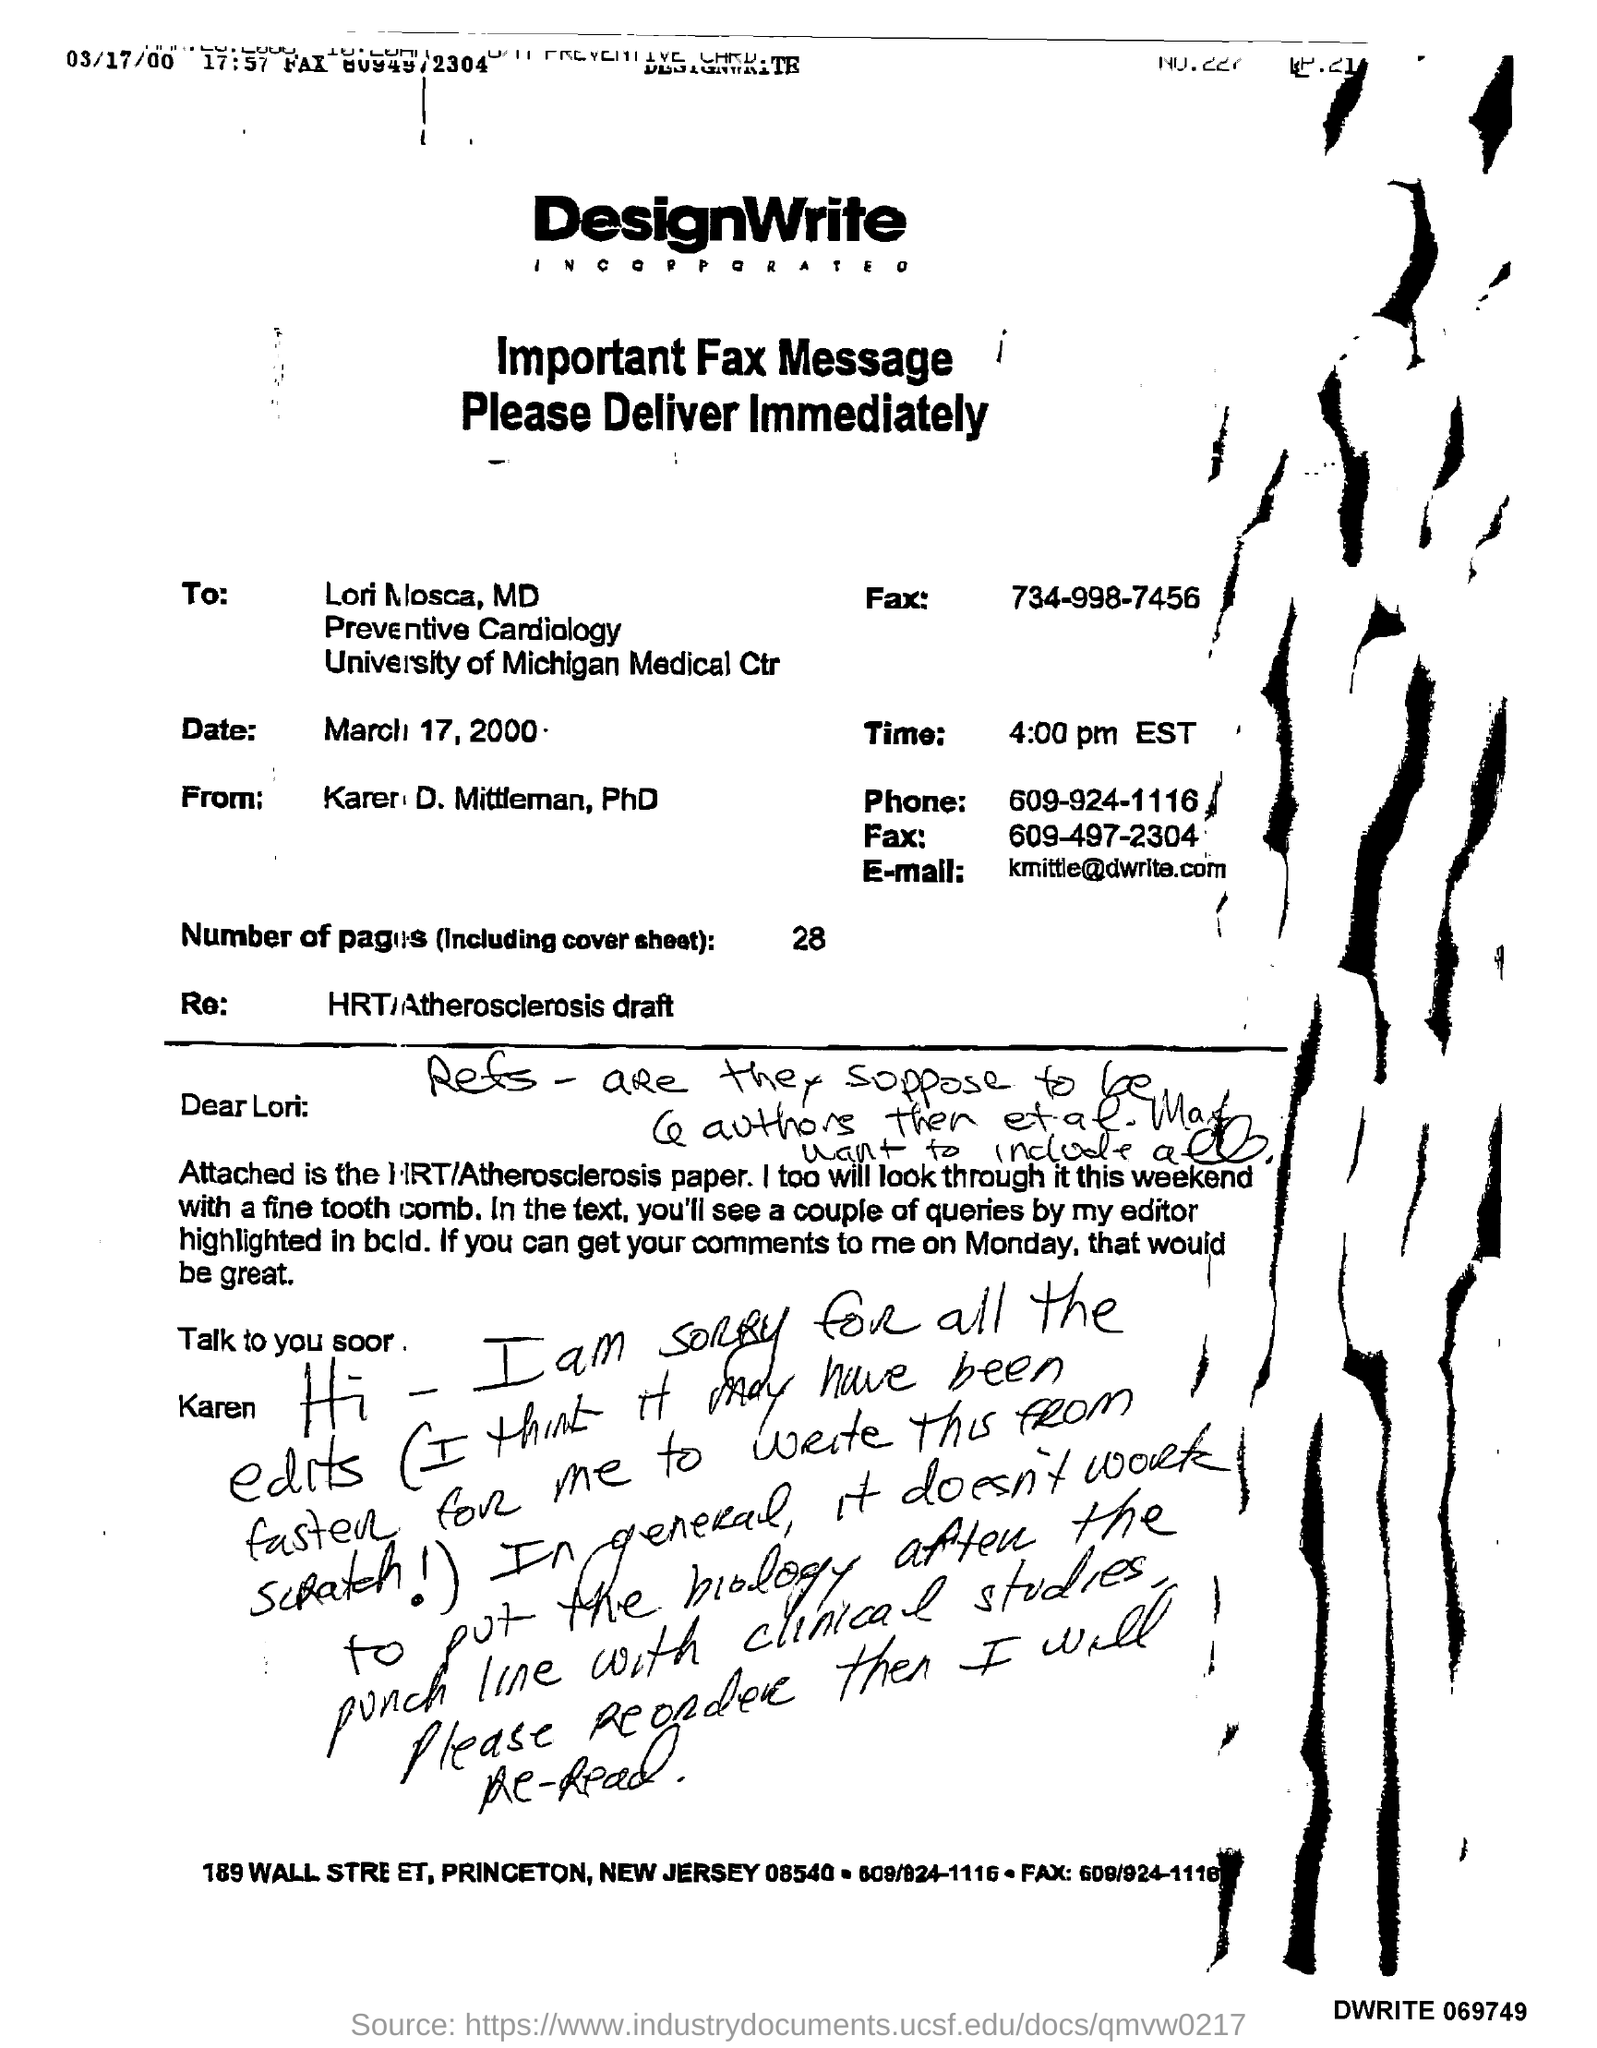To whom this fax message was sent ?
Give a very brief answer. Lori mosca. What is the time mentioned in the given fax message ?
Your answer should be compact. 4:00 pm est. What is the date mentioned in the fax message ?
Provide a short and direct response. March 17, 2000. How many number of pages are there (including cover sheet )?
Your answer should be compact. 28. From whom this fax message was delivered ?
Your answer should be very brief. Karen d. mittleman, ph.d. What is the phone number mentioned in the fax message ?
Your answer should be very brief. 609-924-1116. What is the e-mail mentioned in the given fax message ?
Offer a terse response. Kmittle@dwrite.com. 